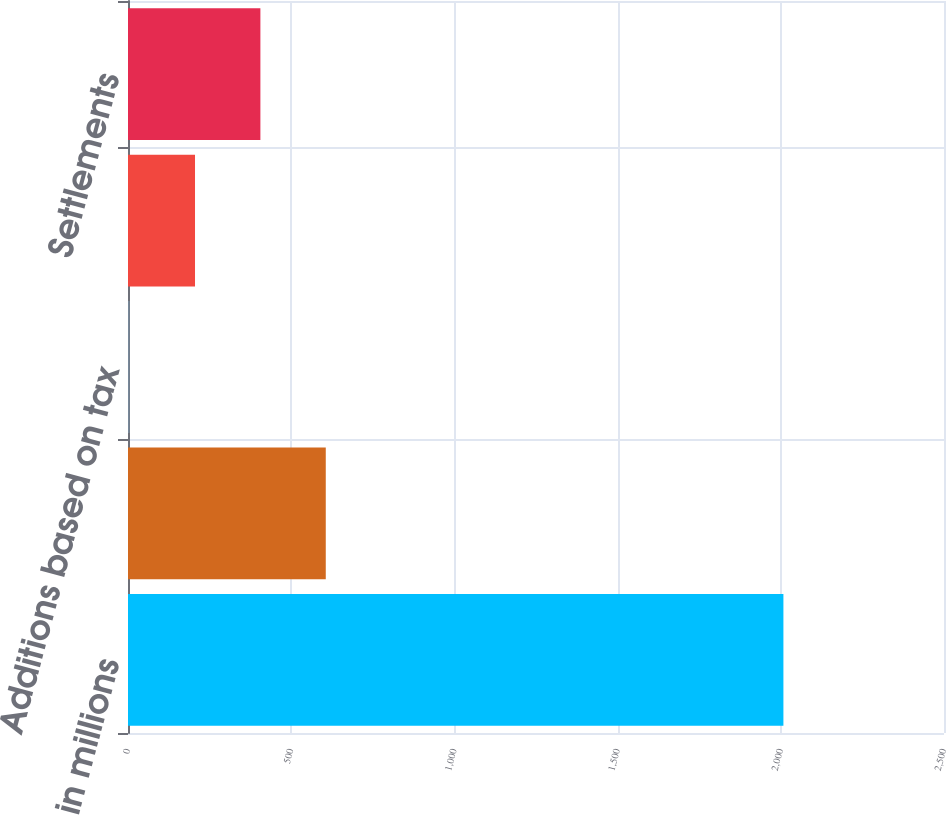Convert chart to OTSL. <chart><loc_0><loc_0><loc_500><loc_500><bar_chart><fcel>in millions<fcel>Unrecognized tax benefit at<fcel>Additions based on tax<fcel>Additions for tax positions of<fcel>Settlements<nl><fcel>2008<fcel>605.9<fcel>5<fcel>205.3<fcel>405.6<nl></chart> 